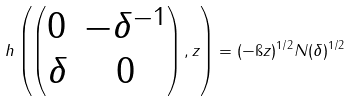<formula> <loc_0><loc_0><loc_500><loc_500>h \left ( \begin{pmatrix} 0 & - \delta ^ { - 1 } \\ \delta & 0 \end{pmatrix} , z \right ) = ( - \i z ) ^ { 1 / 2 } N ( \delta ) ^ { 1 / 2 }</formula> 